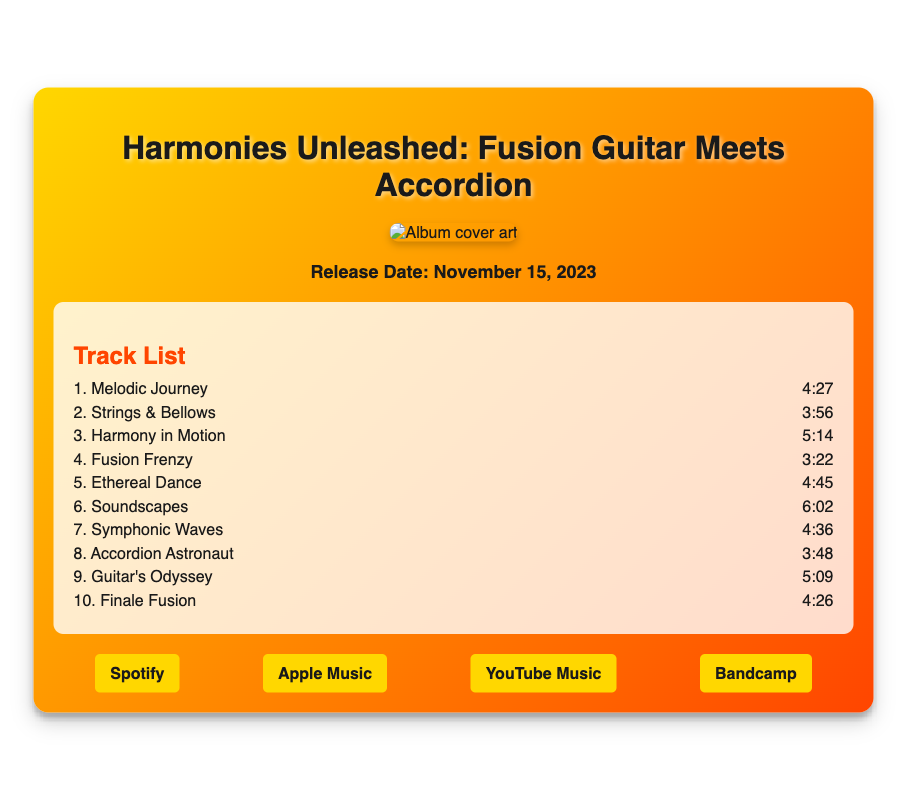What is the title of the album? The title is prominently displayed at the top of the document.
Answer: Harmonies Unleashed: Fusion Guitar Meets Accordion What is the release date of the album? The release date is mentioned clearly in the designated section.
Answer: November 15, 2023 How many tracks are listed in the track list? The number of tracks can be counted from the track section of the document.
Answer: 10 What is the name of the first track? The name of the first track is provided in the track list.
Answer: Melodic Journey Which streaming platform is mentioned first? The order of the streaming platforms is based on their appearance in the document.
Answer: Spotify What is the duration of the track "Finale Fusion"? The duration is given alongside each track in the list.
Answer: 4:26 Which two instruments are highlighted in the album's title? The title explicitly mentions the two instruments featured in the album.
Answer: Guitar and Accordion What color scheme is used for the background of the flyer? The background colors are described as being part of the document's styling.
Answer: Gradient of gold and orange What type of design does the flyer feature? The style and presentation of the document indicate its design approach.
Answer: Sleek and modern What element of the document enhances its visual appeal? The document includes various design features that enhance visuals.
Answer: Cover art with shadow and rounded borders 